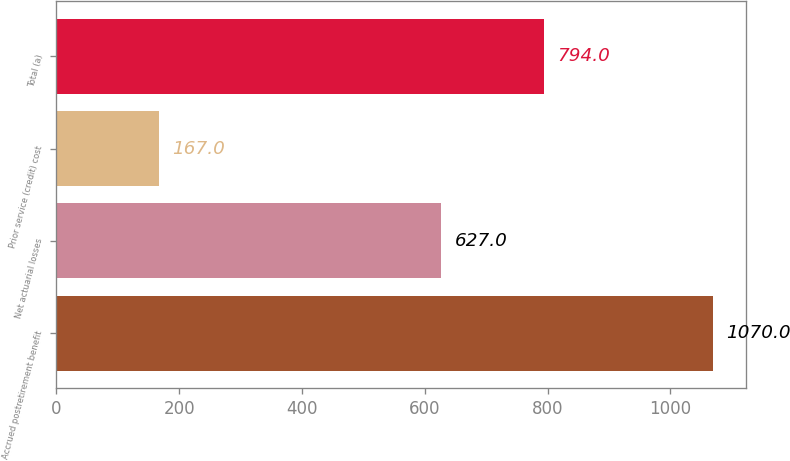<chart> <loc_0><loc_0><loc_500><loc_500><bar_chart><fcel>Accrued postretirement benefit<fcel>Net actuarial losses<fcel>Prior service (credit) cost<fcel>Total (a)<nl><fcel>1070<fcel>627<fcel>167<fcel>794<nl></chart> 